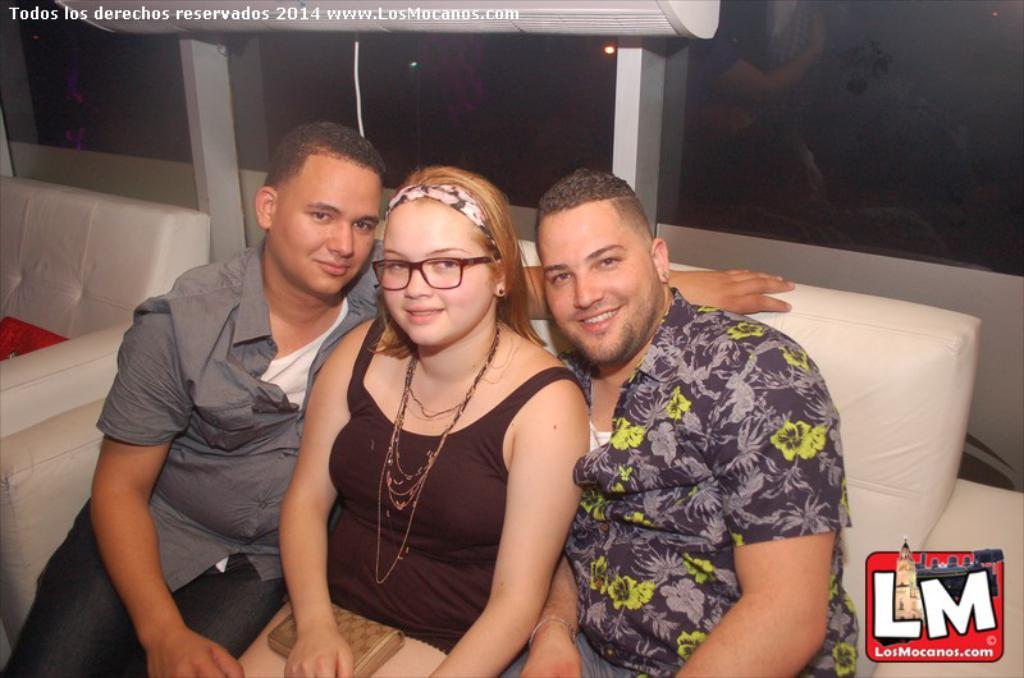Who is the main subject in the foreground of the image? There is a woman in the foreground of the image. What is the woman holding in the image? The woman is holding a wallet. What are the two men in the foreground doing? The two men are sitting on a white couch in the foreground. What can be seen in the background of the image? There is a glass and another couch in the background of the image. Can you see any lake in the image? No, there is no lake present in the image. How does the twig help the woman in the image? There is no twig present in the image, so it cannot help the woman. 